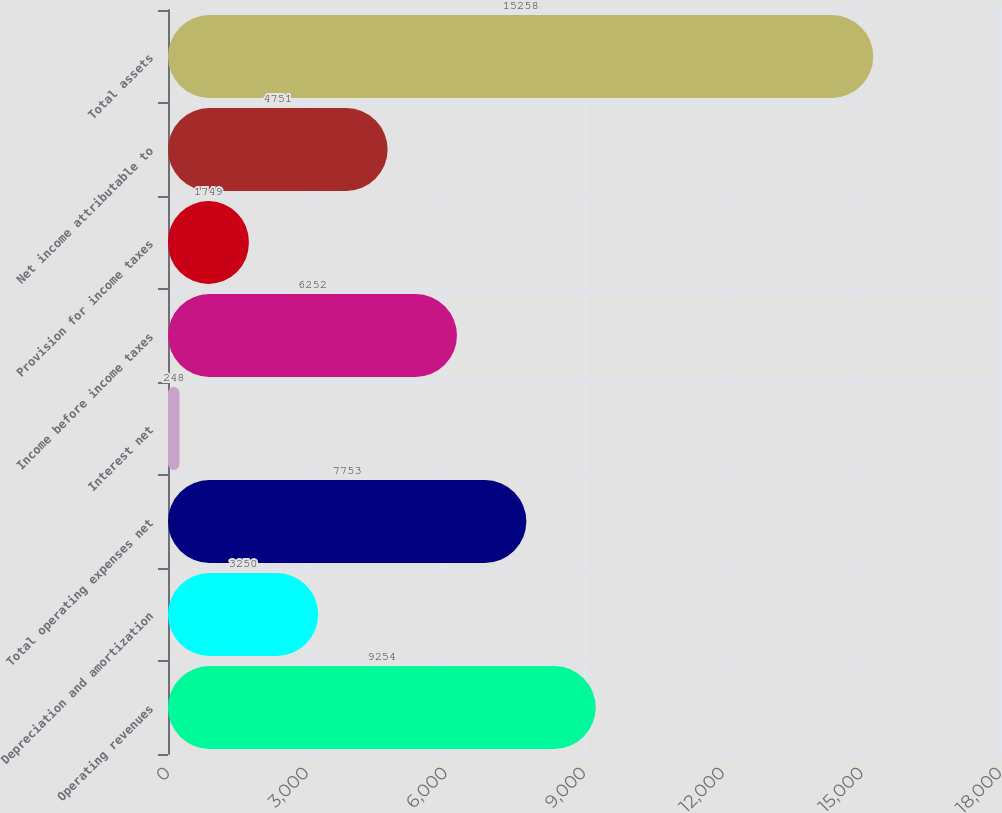Convert chart to OTSL. <chart><loc_0><loc_0><loc_500><loc_500><bar_chart><fcel>Operating revenues<fcel>Depreciation and amortization<fcel>Total operating expenses net<fcel>Interest net<fcel>Income before income taxes<fcel>Provision for income taxes<fcel>Net income attributable to<fcel>Total assets<nl><fcel>9254<fcel>3250<fcel>7753<fcel>248<fcel>6252<fcel>1749<fcel>4751<fcel>15258<nl></chart> 